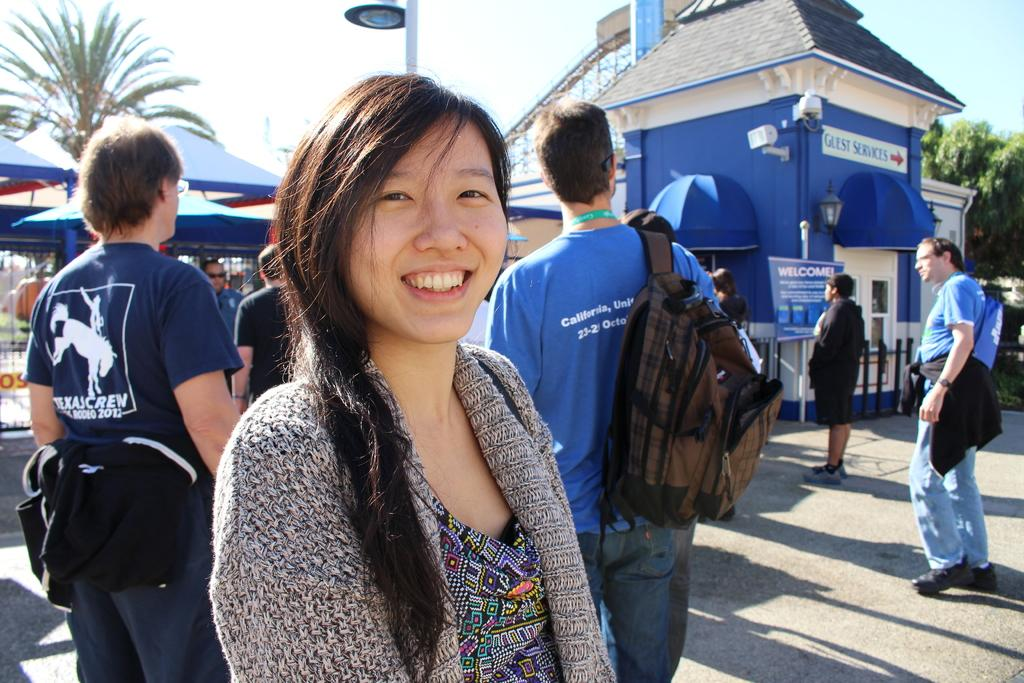Who is the main subject in the image? There is a lady in the center of the image. What is the lady doing in the image? The lady is standing and smiling. What can be seen in the background of the image? There are people, buildings, trees, a pole, and the sky visible in the background of the image. What type of oil can be seen dripping from the lady's hair in the image? There is no oil visible in the image, nor is there any indication that the lady's hair is dripping with oil. 